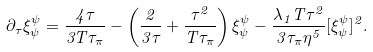<formula> <loc_0><loc_0><loc_500><loc_500>\partial _ { \tau } \xi ^ { \psi } _ { \psi } = \frac { 4 \tau } { 3 T \tau _ { \pi } } - \left ( \frac { 2 } { 3 \tau } + \frac { \tau ^ { 2 } } { T \tau _ { \pi } } \right ) \xi ^ { \psi } _ { \psi } - \frac { \lambda _ { 1 } T \tau ^ { 2 } } { 3 \tau _ { \pi } \eta ^ { 5 } } [ \xi ^ { \psi } _ { \psi } ] ^ { 2 } .</formula> 